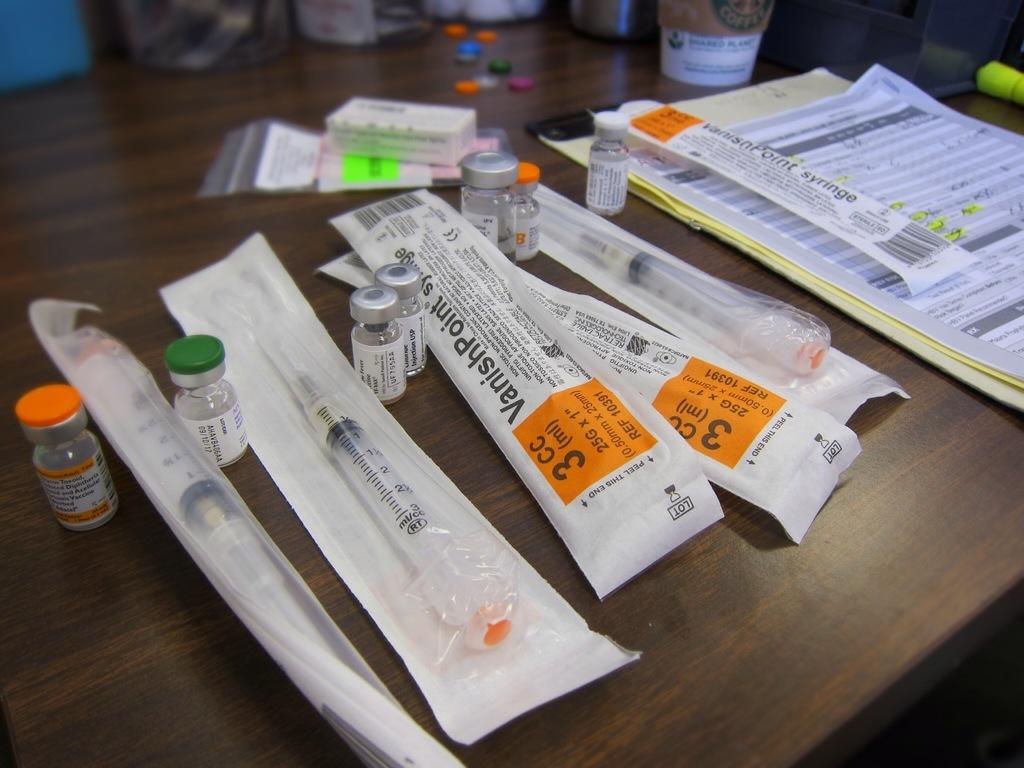<image>
Write a terse but informative summary of the picture. Two syringes that say 3CC on the wrappers sit on a table with medical supplies. 